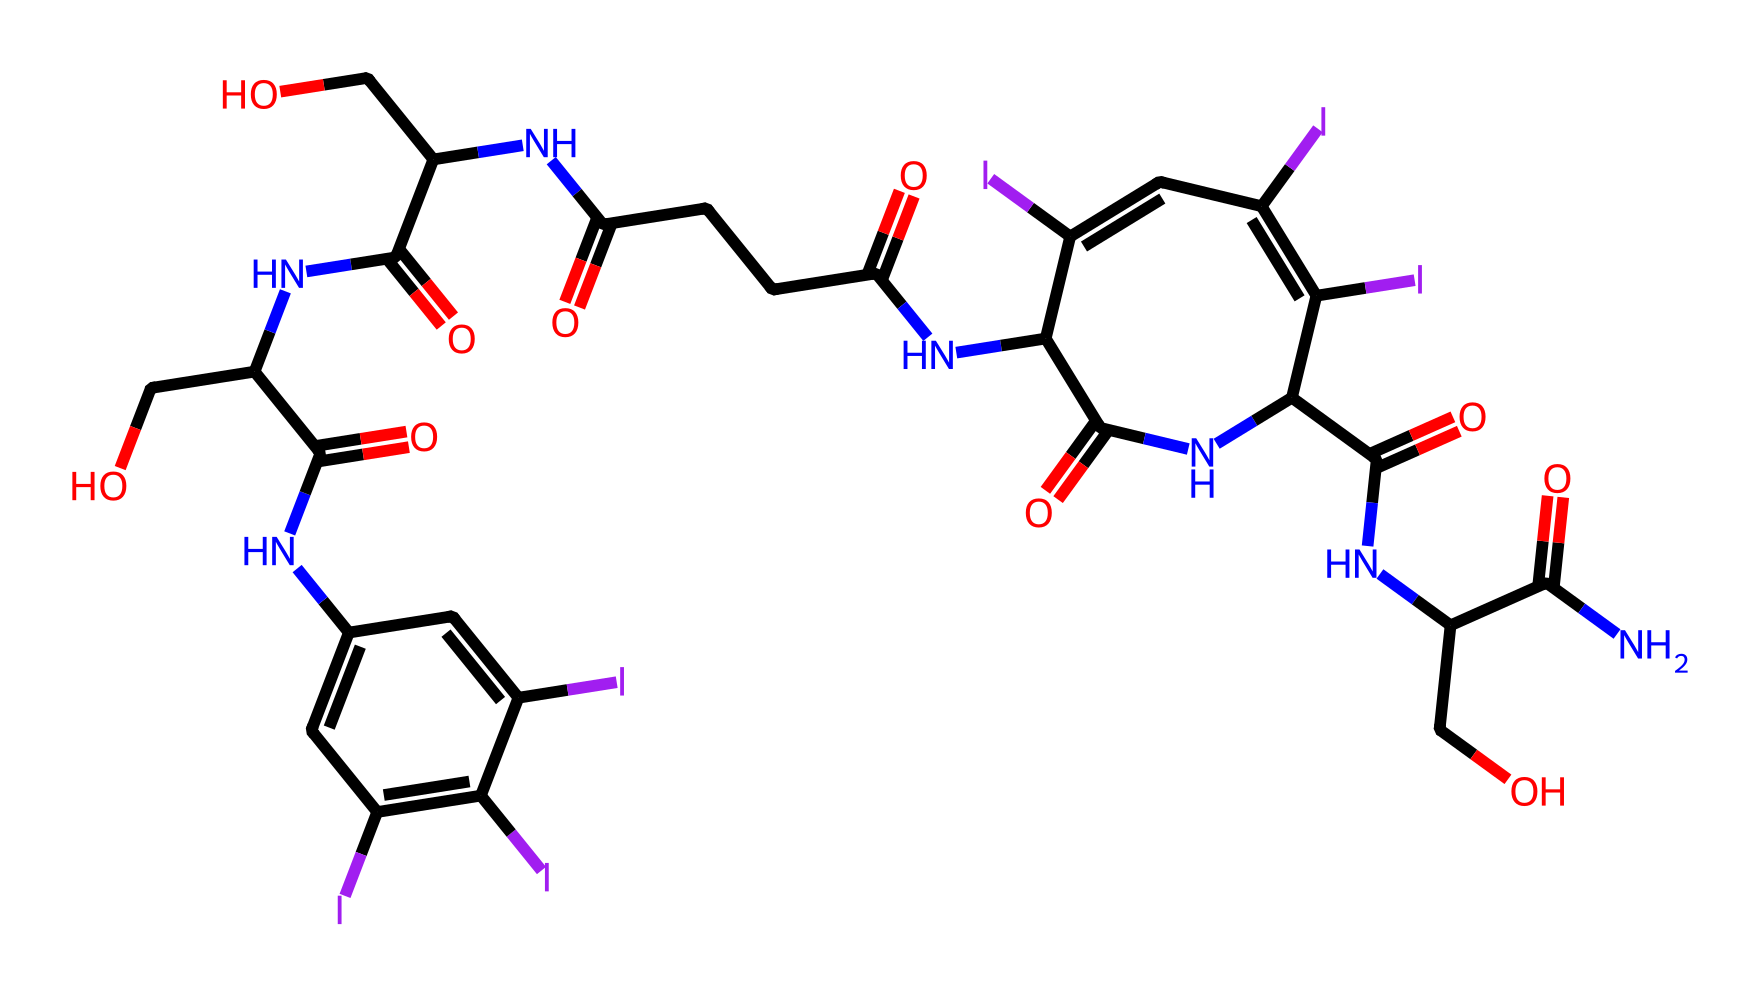What is the primary element present in this chemical? The primary element in the chemical structure is carbon, as it forms the backbone of the structure with many carbon-carbon bonds and is the most abundant element present in the SMILES representation.
Answer: carbon How many nitrogen atoms are present in the chemical? By analyzing the SMILES representation, we can count the occurrences of 'N', which indicates nitrogen atoms. There are a total of 5 'N' symbols in the structure.
Answer: 5 What functional groups are present in this contrast agent? Looking at the chemical structure, the presence of 'NC(=O)' indicates amide functional groups and 'C(=O)' indicates carbonyl groups. Thus, it contains amides and carbonyls.
Answer: amides and carbonyls What is the total degree of unsaturation in this compound? The degree of unsaturation can be calculated based on the number of rings and multiple bonds present; visual inspection of the structure indicates 6 double bonds in addition to the ring structure, leading to a degree of unsaturation of 7.
Answer: 7 What makes this chemical suitable as a contrast agent in imaging? The iodinated structure, indicated by the presence of 'I' in the SMILES, suggests this compound has high radiopacity, which is critical for enhancing contrast in medical imaging such as CT scans.
Answer: high radiopacity What type of bonding predominantly occurs in this molecule? The chemical structure indicates that covalent bonds are primarily present, particularly carbon-nitrogen and carbon-carbon bonds, characteristic of organic compounds.
Answer: covalent bonds 